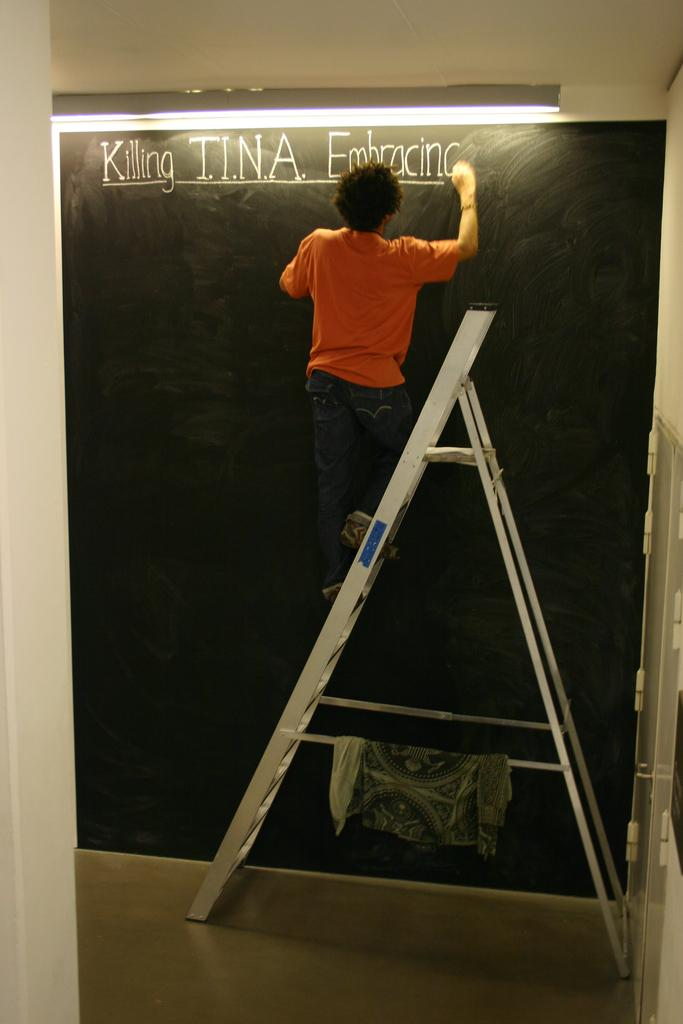Who is the main subject in the image? There is a boy in the image. What is the boy wearing? The boy is wearing an orange t-shirt. What is the boy standing on? The boy is standing on a silver ladder. What is the boy doing in the image? The boy is writing on a blackboard. What flavor of ice cream does the boy prefer, based on the image? There is no information about the boy's ice cream preferences in the image. 